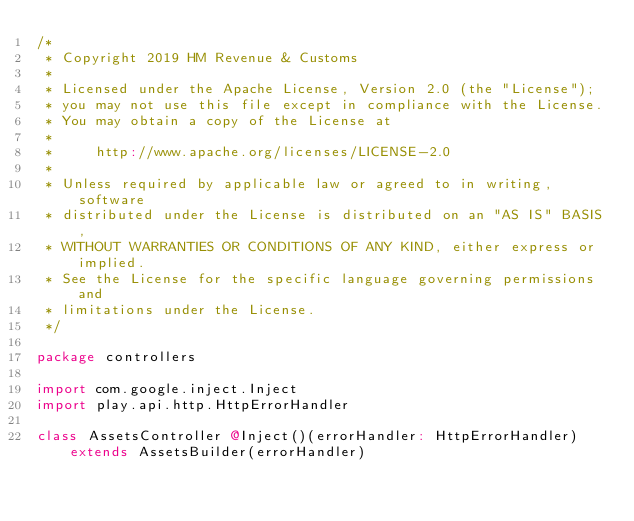<code> <loc_0><loc_0><loc_500><loc_500><_Scala_>/*
 * Copyright 2019 HM Revenue & Customs
 *
 * Licensed under the Apache License, Version 2.0 (the "License");
 * you may not use this file except in compliance with the License.
 * You may obtain a copy of the License at
 *
 *     http://www.apache.org/licenses/LICENSE-2.0
 *
 * Unless required by applicable law or agreed to in writing, software
 * distributed under the License is distributed on an "AS IS" BASIS,
 * WITHOUT WARRANTIES OR CONDITIONS OF ANY KIND, either express or implied.
 * See the License for the specific language governing permissions and
 * limitations under the License.
 */

package controllers

import com.google.inject.Inject
import play.api.http.HttpErrorHandler

class AssetsController @Inject()(errorHandler: HttpErrorHandler) extends AssetsBuilder(errorHandler)
</code> 